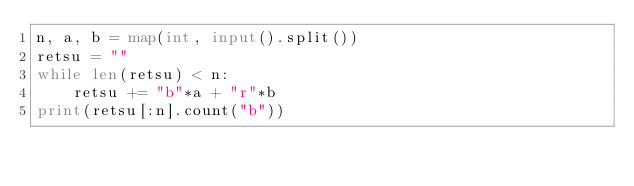<code> <loc_0><loc_0><loc_500><loc_500><_Python_>n, a, b = map(int, input().split())
retsu = ""
while len(retsu) < n:
    retsu += "b"*a + "r"*b
print(retsu[:n].count("b"))</code> 